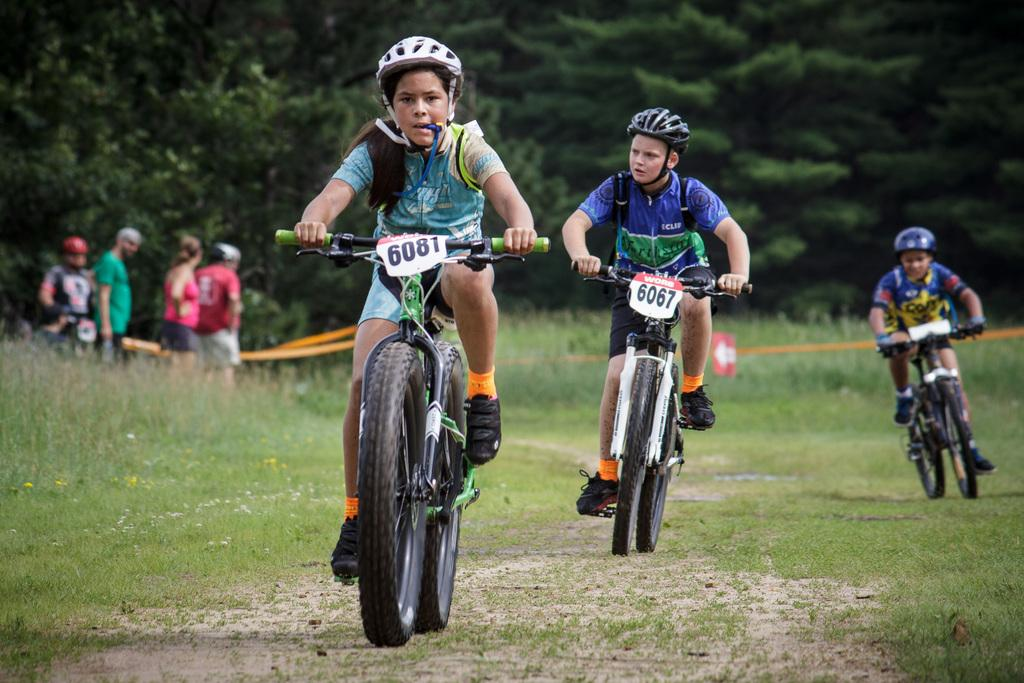Who is present in the image? There are children in the image. What are the children doing in the image? The children are riding bicycles. What type of terrain is visible at the bottom of the image? There is grass visible at the bottom of the image. What can be seen in the background of the image? There are plants, trees, and ropes in the background of the image. Are there any other people visible in the image? Yes, there are people in the background of the image. What type of structure can be seen in the background of the image? There is no structure visible in the background of the image. Can you tell me how many zoo animals are present in the image? There are no zoo animals present in the image. 